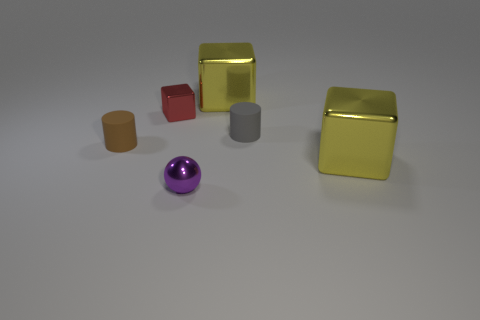There is a rubber cylinder to the left of the gray rubber object; how big is it?
Offer a terse response. Small. What shape is the metal thing that is both in front of the red cube and right of the purple thing?
Make the answer very short. Cube. How many small purple cubes have the same material as the red cube?
Keep it short and to the point. 0. Are there more gray cylinders than big metal things?
Your answer should be compact. No. The tiny metallic sphere has what color?
Offer a very short reply. Purple. Is the color of the cylinder that is behind the brown cylinder the same as the small shiny ball?
Your answer should be very brief. No. What number of rubber things have the same color as the tiny metal block?
Offer a terse response. 0. Do the thing that is to the left of the small red thing and the tiny gray object have the same shape?
Ensure brevity in your answer.  Yes. Is the number of tiny shiny objects that are in front of the small gray matte object less than the number of small brown objects in front of the tiny purple sphere?
Your answer should be compact. No. There is a cylinder that is to the right of the brown object; what is it made of?
Make the answer very short. Rubber. 